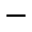Convert formula to latex. <formula><loc_0><loc_0><loc_500><loc_500>^ { - }</formula> 